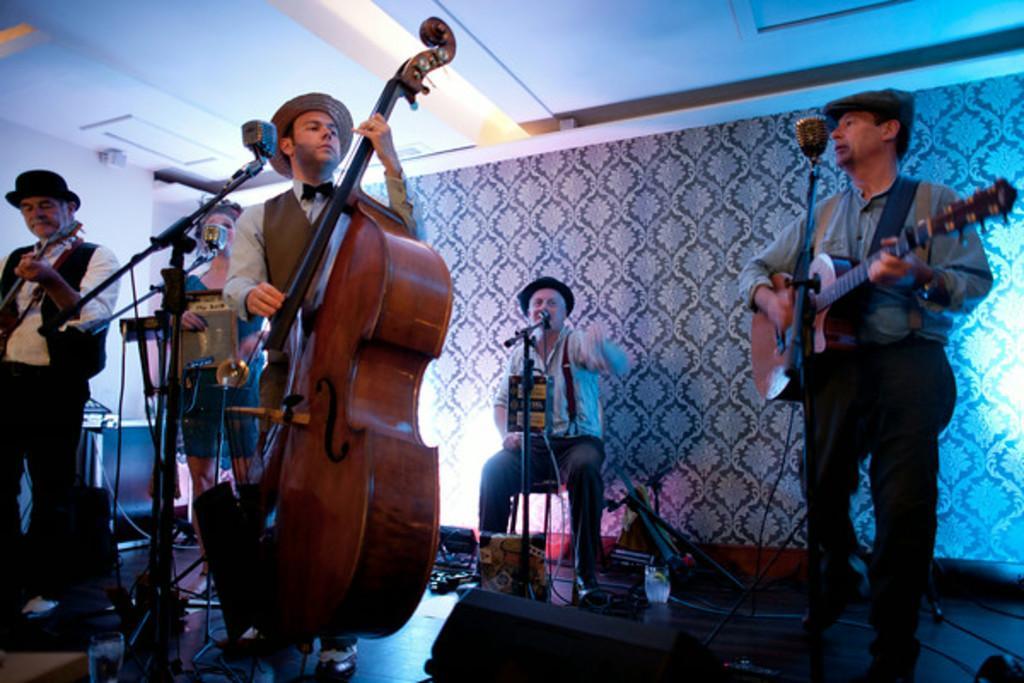How would you summarize this image in a sentence or two? In this picture we can see five persons on stage where four are standing playing guitar and violin and at back of them person sitting on chair and singing on mic and woman playing accordion and in background we can see wall. 